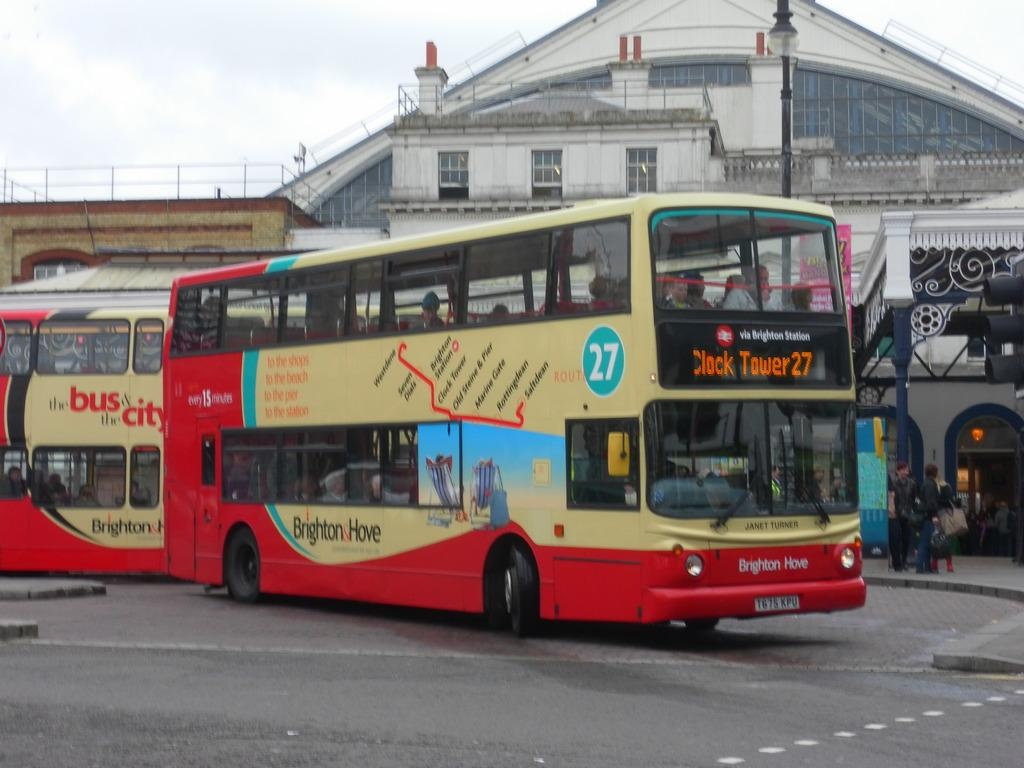<image>
Give a short and clear explanation of the subsequent image. A bus via Brighton Station displays a sign for Clock tower 27. 